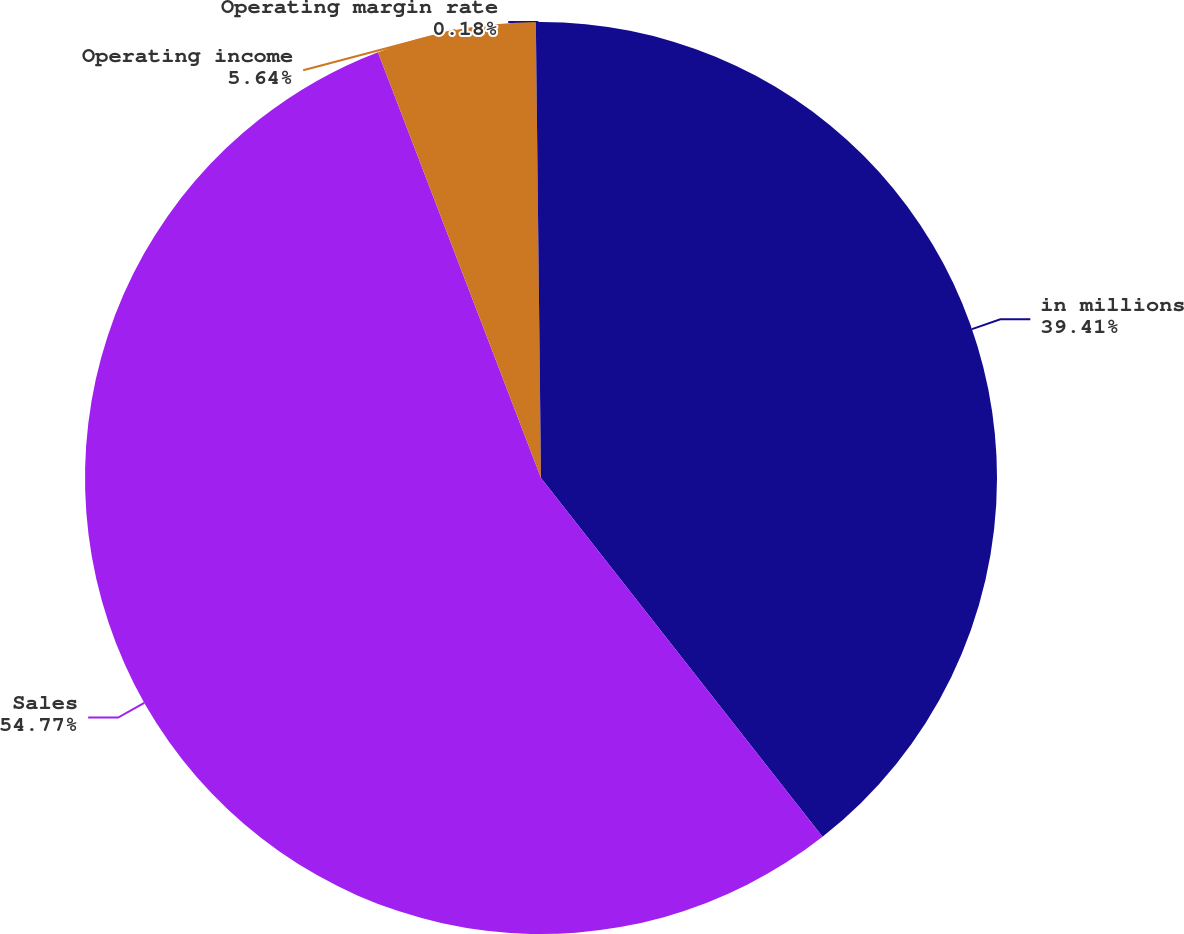Convert chart to OTSL. <chart><loc_0><loc_0><loc_500><loc_500><pie_chart><fcel>in millions<fcel>Sales<fcel>Operating income<fcel>Operating margin rate<nl><fcel>39.41%<fcel>54.77%<fcel>5.64%<fcel>0.18%<nl></chart> 